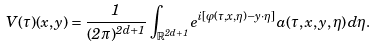<formula> <loc_0><loc_0><loc_500><loc_500>V ( \tau ) ( x , y ) = \frac { 1 } { ( 2 \pi ) ^ { 2 d + 1 } } \, \int _ { \mathbb { R } ^ { 2 d + 1 } } e ^ { i [ \varphi ( \tau , x , \eta ) - y \cdot \eta ] } \, a ( \tau , x , y , \eta ) \, d \eta .</formula> 